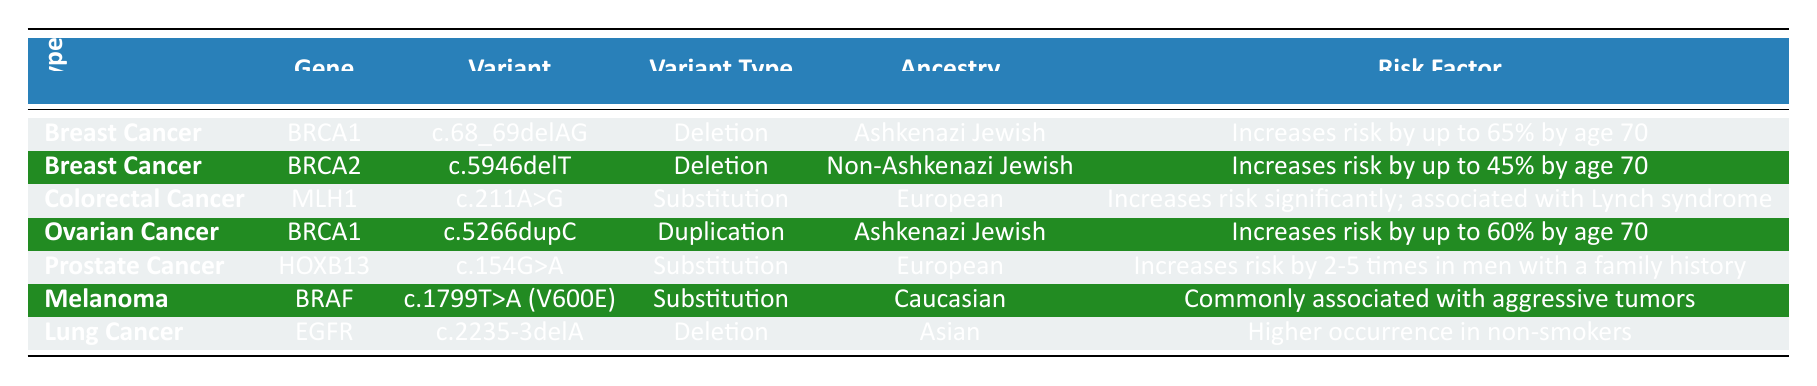What is the risk factor associated with the BRCA1 gene variant c.68_69delAG in Breast Cancer? The risk factor for the BRCA1 gene variant c.68_69delAG in Breast Cancer is mentioned in the table as "Increases risk by up to 65% by age 70".
Answer: Increases risk by up to 65% by age 70 Which ancestry is linked to the BRCA2 gene variant c.5946delT? The ancestry linked to the BRCA2 gene variant c.5946delT is "Non-Ashkenazi Jewish", as shown in the corresponding row of the table.
Answer: Non-Ashkenazi Jewish Is the EGFR gene variant c.2235-3delA associated with a higher occurrence in smokers? The table states that the EGFR gene variant c.2235-3delA has a "Higher occurrence in non-smokers", indicating that this statement is false.
Answer: No How many types of cancer are associated with the BRCA1 gene? The table lists two variants associated with the BRCA1 gene, one for Breast Cancer and one for Ovarian Cancer. Therefore, there are two types of cancer linked to this gene.
Answer: 2 Which cancer type has the highest mentioned risk factor increase and what is that percentage? The table indicates that the Breast Cancer variant (BRCA1: c.68_69delAG) has the highest risk factor increase at up to 65% by age 70, compared to other entries.
Answer: Breast Cancer, up to 65% What is the difference in risk factor percentages between the BRCA1 and BRCA2 gene variants in Breast Cancer? The BRCA1 variant has an increased risk of up to 65% and the BRCA2 variant has an increased risk of up to 45%. The difference can be calculated as 65% - 45% = 20%.
Answer: 20% Which specific variant type is shared between the BRCA1 gene variants and what cancer type do they relate to? The deletion variant type is shared by the BRCA1 gene variant in Breast Cancer (c.68_69delAG) and the duplication variant type for Ovarian Cancer (c.5266dupC).
Answer: Deletion, Breast Cancer Are all the variants listed in the table linked to increased cancer risk? Each of the variants listed in the table has an associated risk factor that indicates an increase in cancer risk in their respective cancer types.
Answer: Yes What is the risk factor for men with a family history linked to HOXB13 in Prostate Cancer? The associated risk factor for the HOXB13 gene variant c.154G>A in Prostate Cancer indicates an increase in risk by 2-5 times in men with a family history.
Answer: Increases risk by 2-5 times 